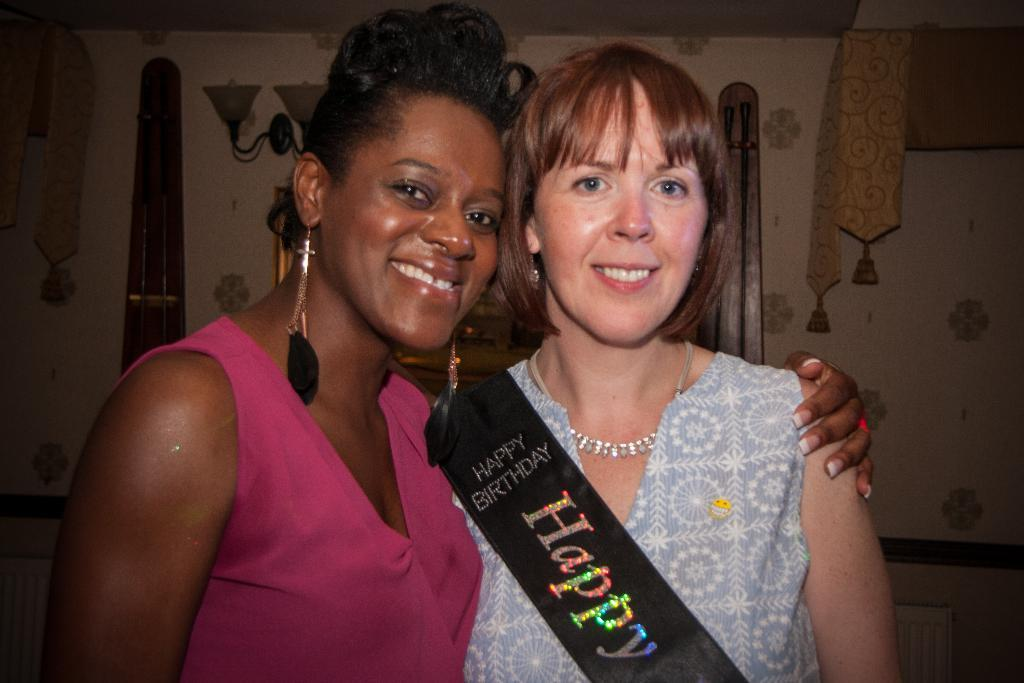How many people are in the image? There are two persons in the image. What is the facial expression of the persons? The persons are smiling. What is located behind the persons? There is a wall, light, and an object behind the persons. What type of surprise can be seen on the wall behind the persons? There is no surprise visible on the wall behind the persons; the image only shows a wall, light, and an object. 